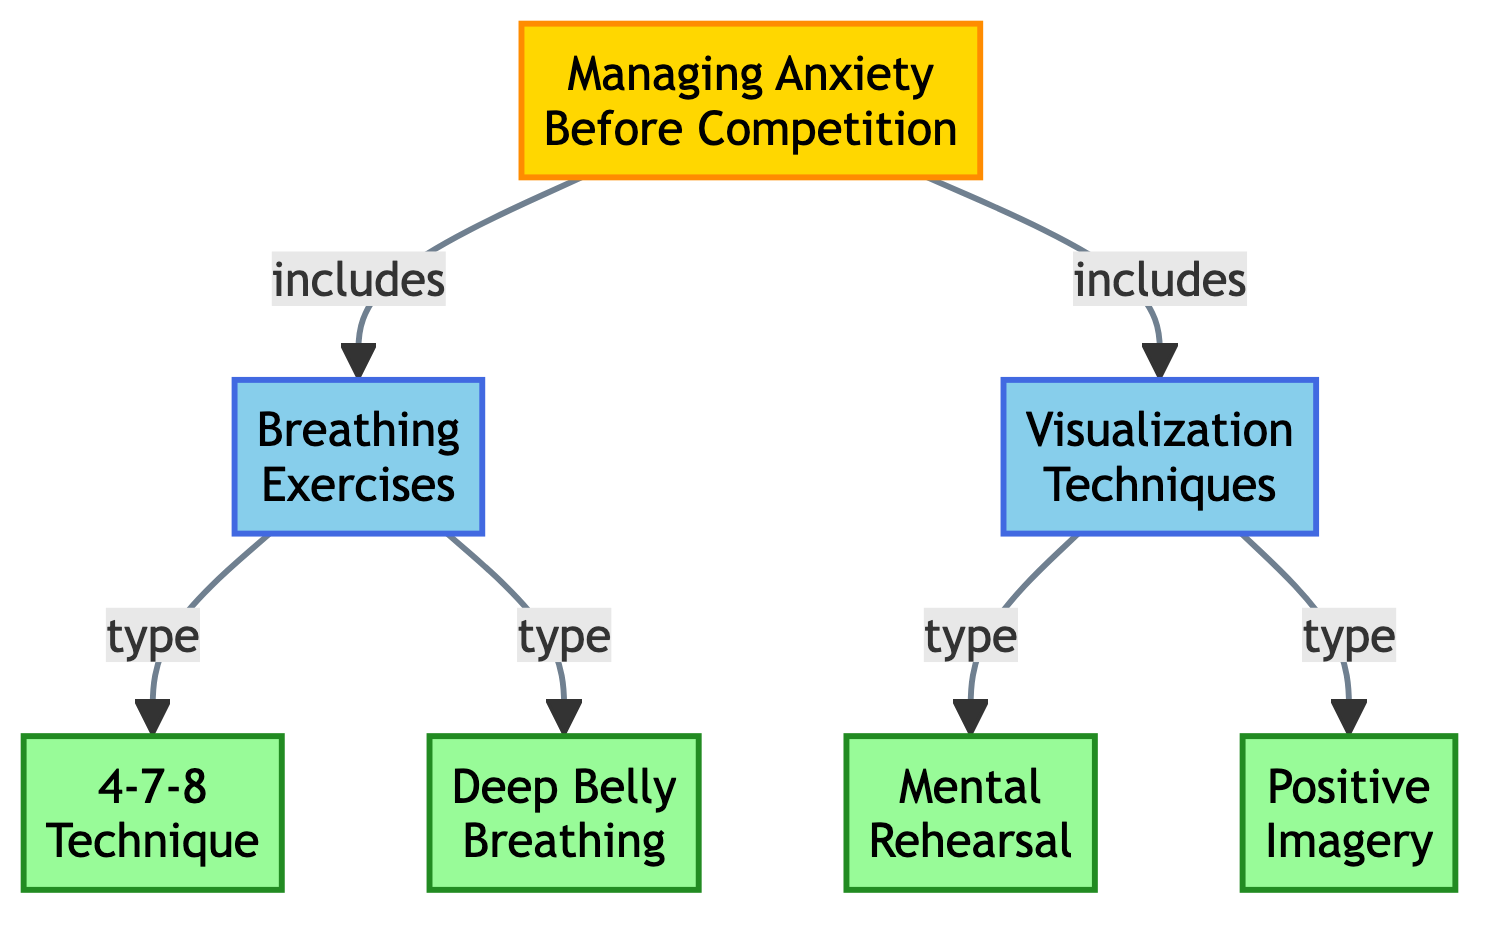What is the main focus of the diagram? The diagram focuses on "Managing Anxiety Before Competition," as indicated at the top node.
Answer: Managing Anxiety Before Competition How many breathing exercise types are mentioned in the diagram? The diagram lists two types of breathing exercises: "4-7-8 Technique" and "Deep Belly Breathing."
Answer: 2 What technique is categorized under visualization techniques? The technique categorized under visualization techniques is "Mental Rehearsal."
Answer: Mental Rehearsal Which node directly branches from "Breathing Exercises"? The nodes that directly branch from "Breathing Exercises" are "4-7-8 Technique" and "Deep Belly Breathing."
Answer: Both 4-7-8 Technique and Deep Belly Breathing What is the relationship between "Managing Anxiety Before Competition" and "Visualization Techniques"? "Managing Anxiety Before Competition" includes "Visualization Techniques" as indicated by the arrow connecting them.
Answer: includes Can you name one of the two types of visualization techniques listed? One of the two types listed is "Positive Imagery."
Answer: Positive Imagery How many main categories are included in the diagram? The diagram includes two main categories: "Breathing Exercises" and "Visualization Techniques."
Answer: 2 Which technique flows from "Breathing Exercises"? The flow from "Breathing Exercises" includes both "4-7-8 Technique" and "Deep Belly Breathing."
Answer: 4-7-8 Technique and Deep Belly Breathing Explain the flow relationship between "Deep Belly Breathing" and "Managing Anxiety Before Competition." "Deep Belly Breathing" is a sub-node under the main category "Breathing Exercises," which itself is a part of "Managing Anxiety Before Competition." This shows a hierarchical structure where "Managing Anxiety Before Competition" leads to "Breathing Exercises," which then leads to "Deep Belly Breathing."
Answer: Leads to 